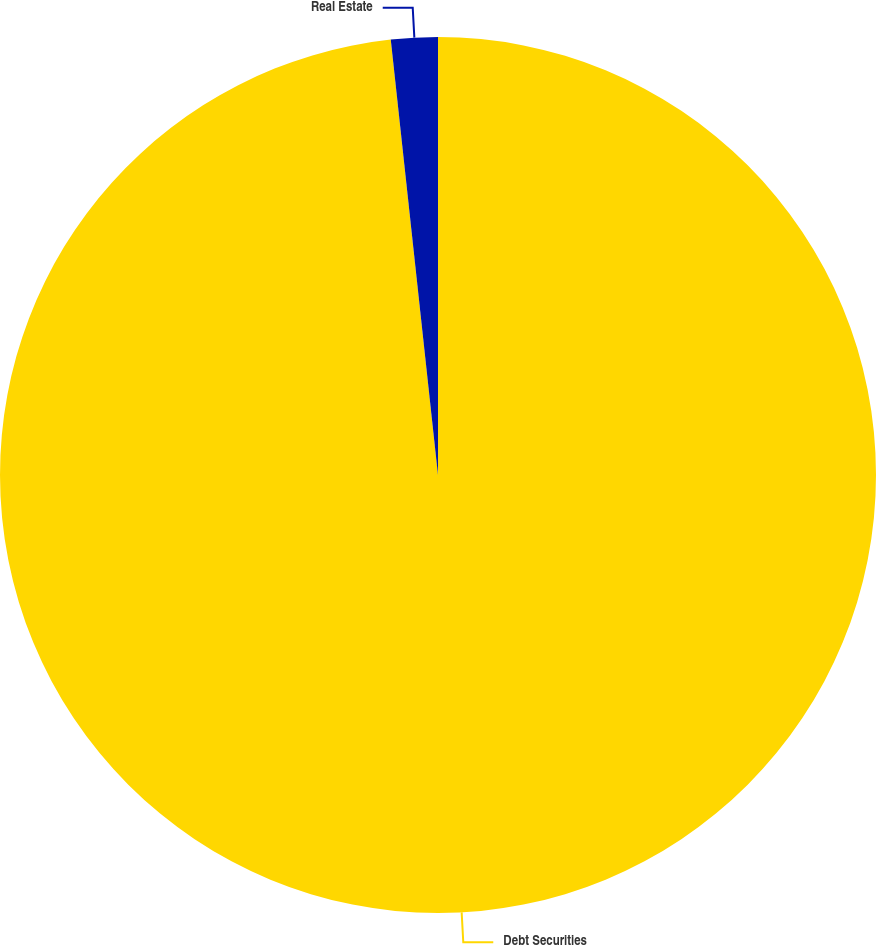<chart> <loc_0><loc_0><loc_500><loc_500><pie_chart><fcel>Debt Securities<fcel>Real Estate<nl><fcel>98.28%<fcel>1.72%<nl></chart> 